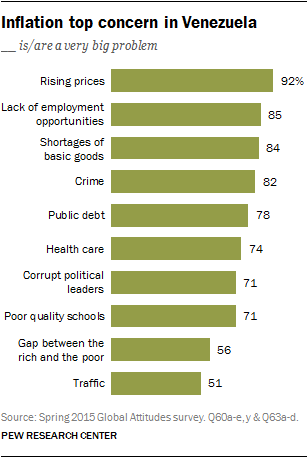Specify some key components in this picture. The sum of the last two green bars indicates a trend of rising prices. There are 10 categories in the chart. 